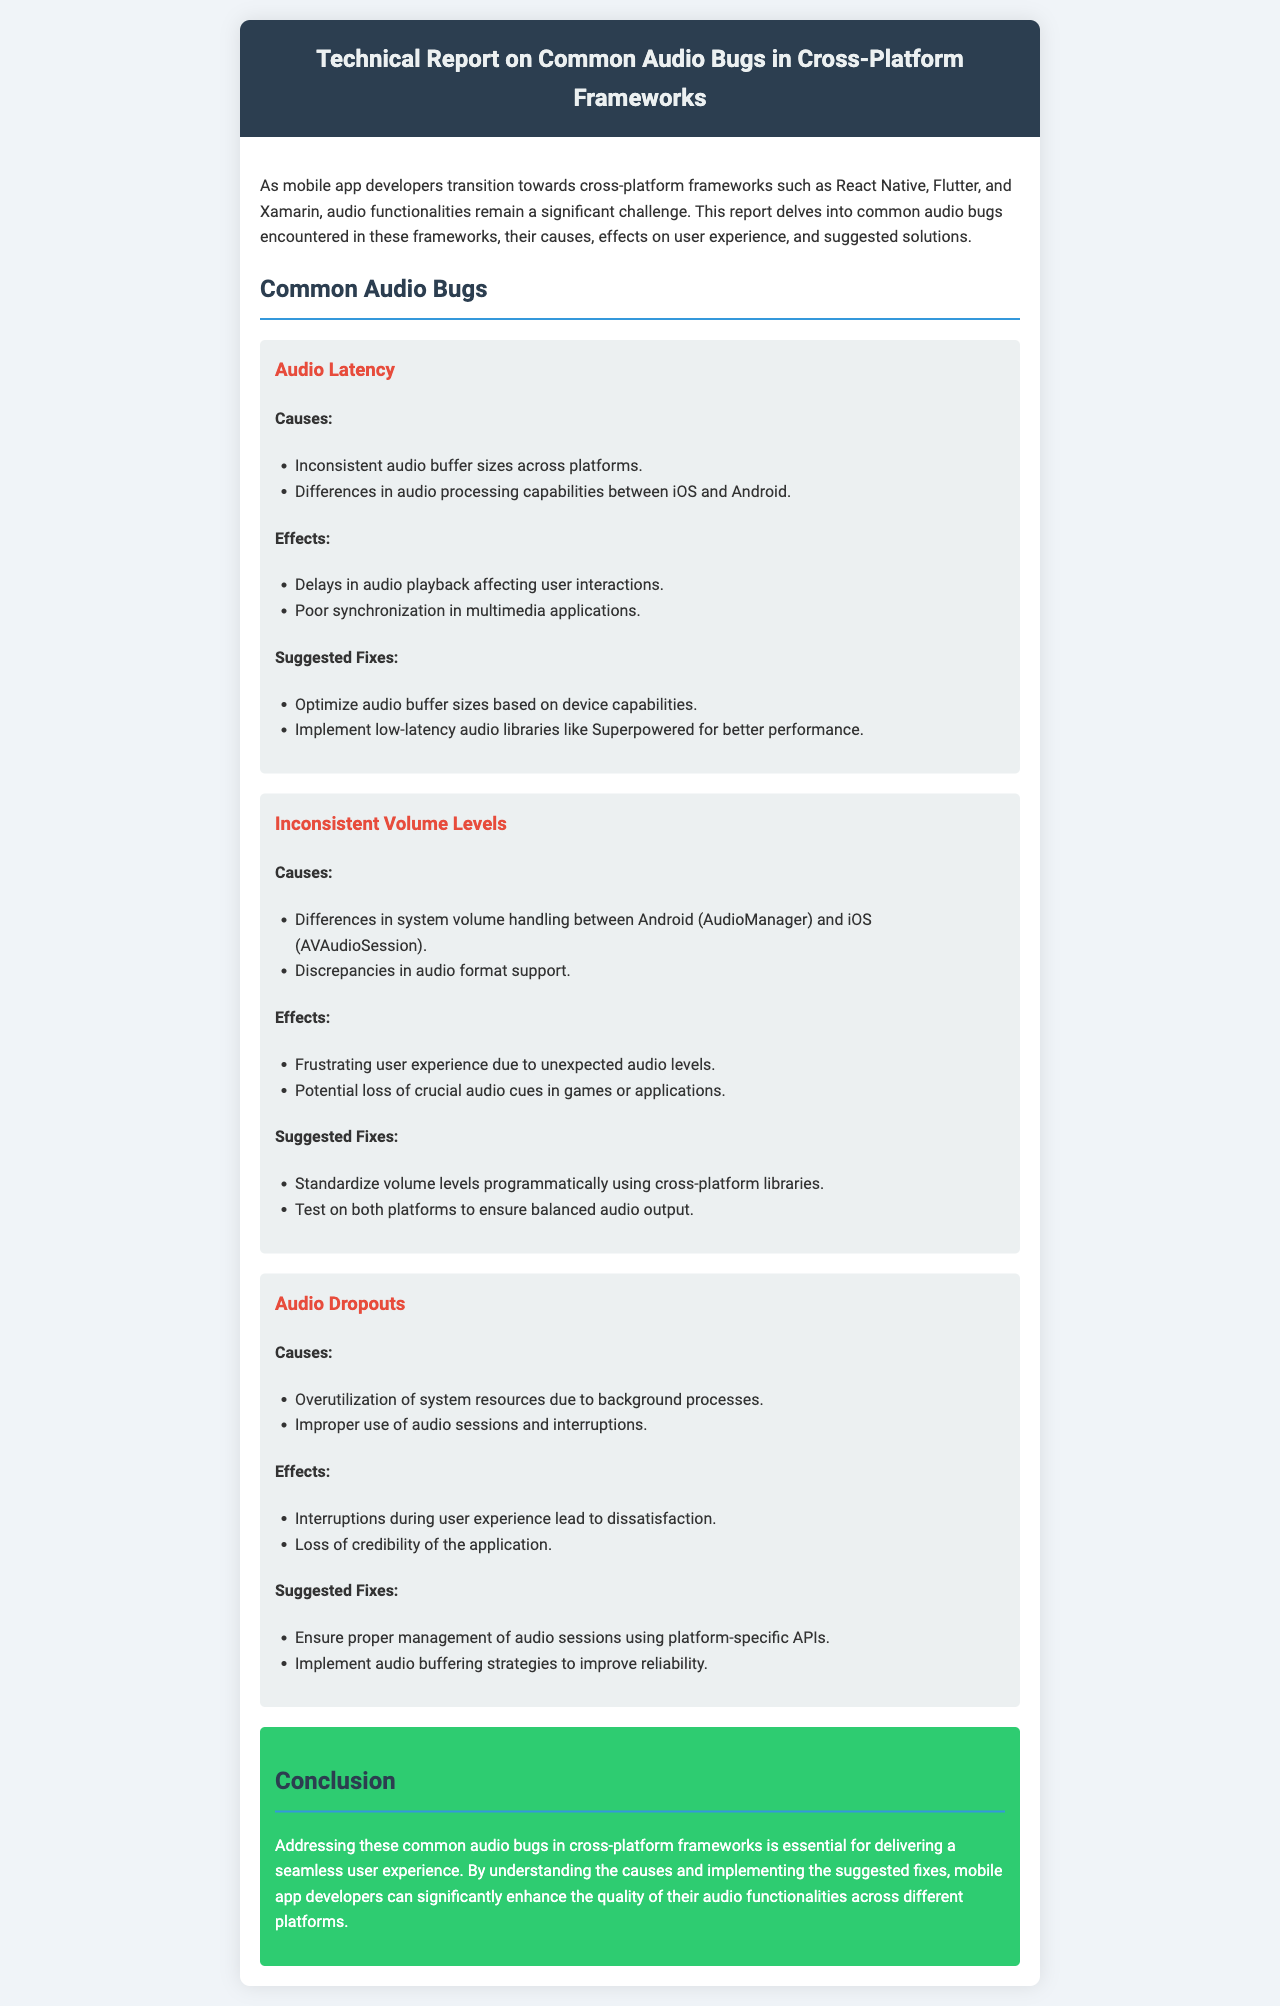What is the title of the report? The title is stated in the header of the document.
Answer: Technical Report on Common Audio Bugs in Cross-Platform Frameworks How many common audio bugs are discussed in the report? The report lists three specific common audio bugs.
Answer: Three What are the suggested fixes for audio latency? The suggested fixes are provided in the respective section of the document under audio latency.
Answer: Optimize audio buffer sizes based on device capabilities; Implement low-latency audio libraries like Superpowered for better performance What causes inconsistent volume levels? The causes for inconsistent volume levels can be found in the specific section of the report.
Answer: Differences in system volume handling between Android (AudioManager) and iOS (AVAudioSession); Discrepancies in audio format support What effect do audio dropouts have on user experience? The effects can be identified under the audio dropouts section of the document.
Answer: Interruptions during user experience lead to dissatisfaction 